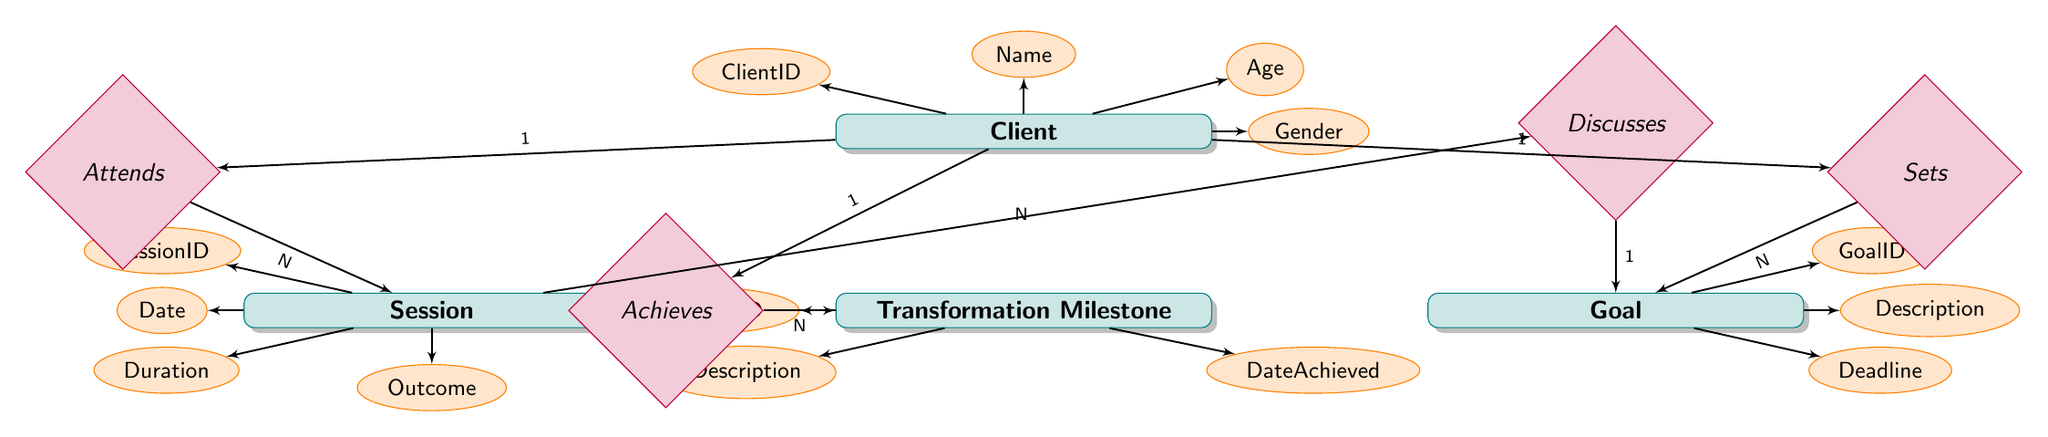what is the total number of entities in the diagram? The diagram contains four entities: Client, Goal, Session, and Transformation Milestone. Counting each of them gives a total of four.
Answer: 4 what is the primary relationship type between Client and Goal? The relationship between Client and Goal is represented by the "Sets" relationship, which is a one-to-many type. This indicates that one client can set multiple goals.
Answer: one-to-many how many attributes does the Session entity have? The Session entity has four attributes, which are SessionID, Date, Duration, and Outcome. Counting these attributes gives a total of four.
Answer: 4 which entity directly connects to the Transformation Milestone entity? The Transformation Milestone entity is directly connected to the Client entity through the "Achieves" relationship. This indicates that a client can achieve multiple transformation milestones.
Answer: Client which relationship connects Session and Goal? The relationship connecting Session and Goal is called "Discusses". This relationship is of many-to-one type, meaning a session can discuss one goal, but one goal can be discussed in many sessions.
Answer: Discusses how many clients can attend multiple sessions based on the diagram? According to the diagram, the relationship "Attends" indicates that one client can attend multiple sessions (one-to-many). Hence, a single client can attend the multiple sessions.
Answer: one what kind of milestones can a client achieve in their transformation journey? The diagram signifies that a client can achieve various milestones documented in the Transformation Milestone entity. These milestones will have specific descriptions and dates achieved, indicating clear progress in their transformation journey.
Answer: Transformation Milestones what do the attributes of the Goal entity describe? The attributes of the Goal entity, which include GoalID, Description, and Deadline, describe the identifier of the goal, the goal's content or objective, and the target date for completion, respectively.
Answer: Goal attributes which type of relationship is responsible for linking Sessions to Goals in the diagram? The relationship that links Sessions to Goals in the diagram is the "Discusses" relationship, which reflects that each session can cover a goal, but each goal can be associated with multiple sessions.
Answer: Discusses 